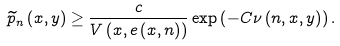<formula> <loc_0><loc_0><loc_500><loc_500>\widetilde { p } _ { n } \left ( x , y \right ) \geq \frac { c } { V \left ( x , e \left ( x , n \right ) \right ) } \exp \left ( - C \nu \left ( n , x , y \right ) \right ) .</formula> 